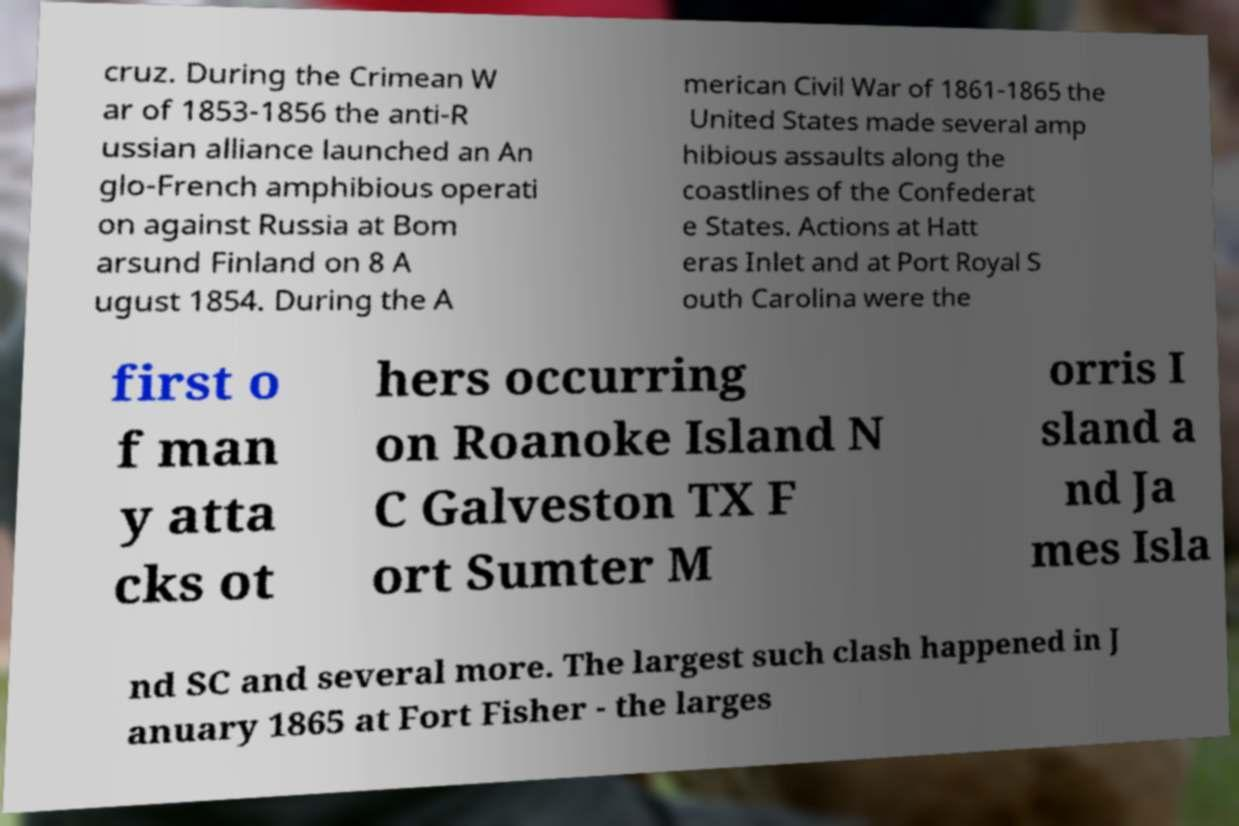For documentation purposes, I need the text within this image transcribed. Could you provide that? cruz. During the Crimean W ar of 1853-1856 the anti-R ussian alliance launched an An glo-French amphibious operati on against Russia at Bom arsund Finland on 8 A ugust 1854. During the A merican Civil War of 1861-1865 the United States made several amp hibious assaults along the coastlines of the Confederat e States. Actions at Hatt eras Inlet and at Port Royal S outh Carolina were the first o f man y atta cks ot hers occurring on Roanoke Island N C Galveston TX F ort Sumter M orris I sland a nd Ja mes Isla nd SC and several more. The largest such clash happened in J anuary 1865 at Fort Fisher - the larges 